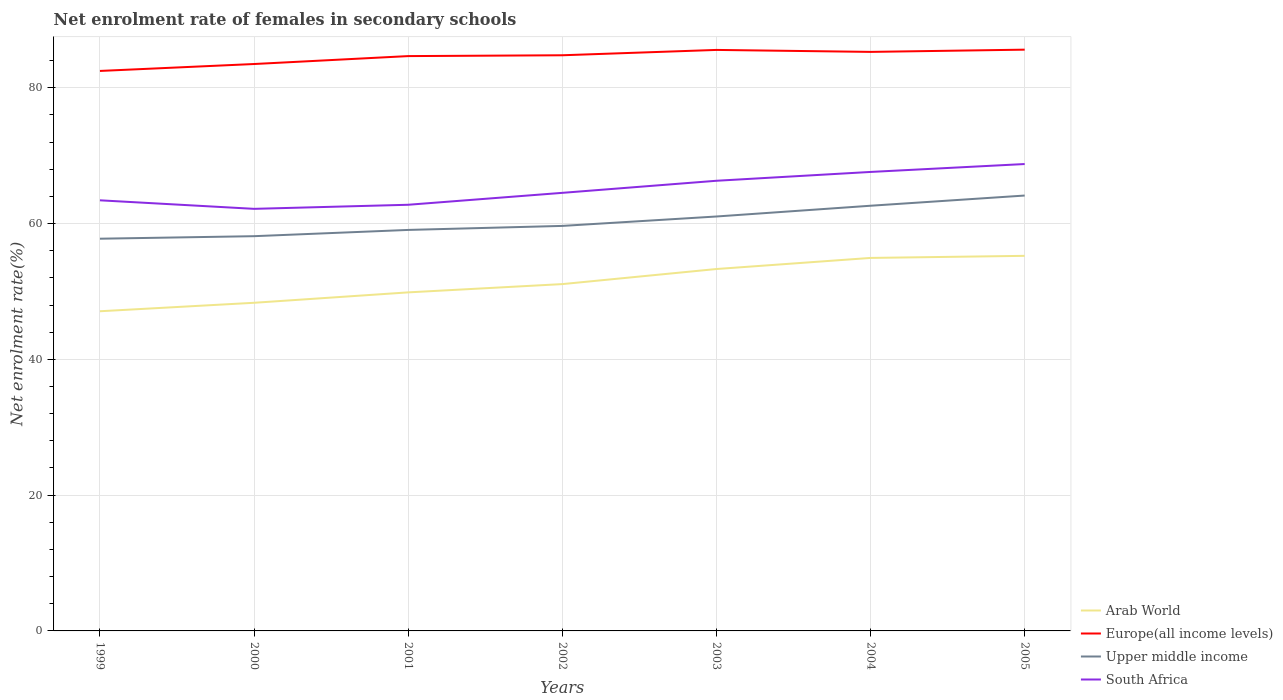How many different coloured lines are there?
Provide a short and direct response. 4. Is the number of lines equal to the number of legend labels?
Offer a very short reply. Yes. Across all years, what is the maximum net enrolment rate of females in secondary schools in Arab World?
Give a very brief answer. 47.08. In which year was the net enrolment rate of females in secondary schools in Upper middle income maximum?
Provide a short and direct response. 1999. What is the total net enrolment rate of females in secondary schools in South Africa in the graph?
Offer a very short reply. -1.78. What is the difference between the highest and the second highest net enrolment rate of females in secondary schools in Upper middle income?
Provide a succinct answer. 6.36. What is the difference between the highest and the lowest net enrolment rate of females in secondary schools in South Africa?
Your answer should be compact. 3. How many lines are there?
Give a very brief answer. 4. What is the difference between two consecutive major ticks on the Y-axis?
Provide a short and direct response. 20. How many legend labels are there?
Give a very brief answer. 4. How are the legend labels stacked?
Make the answer very short. Vertical. What is the title of the graph?
Offer a very short reply. Net enrolment rate of females in secondary schools. What is the label or title of the Y-axis?
Keep it short and to the point. Net enrolment rate(%). What is the Net enrolment rate(%) in Arab World in 1999?
Make the answer very short. 47.08. What is the Net enrolment rate(%) in Europe(all income levels) in 1999?
Your response must be concise. 82.48. What is the Net enrolment rate(%) in Upper middle income in 1999?
Your answer should be very brief. 57.77. What is the Net enrolment rate(%) in South Africa in 1999?
Your response must be concise. 63.43. What is the Net enrolment rate(%) in Arab World in 2000?
Provide a short and direct response. 48.33. What is the Net enrolment rate(%) of Europe(all income levels) in 2000?
Offer a terse response. 83.5. What is the Net enrolment rate(%) in Upper middle income in 2000?
Keep it short and to the point. 58.14. What is the Net enrolment rate(%) of South Africa in 2000?
Your response must be concise. 62.17. What is the Net enrolment rate(%) of Arab World in 2001?
Your response must be concise. 49.86. What is the Net enrolment rate(%) of Europe(all income levels) in 2001?
Your answer should be very brief. 84.67. What is the Net enrolment rate(%) of Upper middle income in 2001?
Provide a succinct answer. 59.06. What is the Net enrolment rate(%) in South Africa in 2001?
Provide a succinct answer. 62.77. What is the Net enrolment rate(%) in Arab World in 2002?
Offer a terse response. 51.08. What is the Net enrolment rate(%) of Europe(all income levels) in 2002?
Offer a very short reply. 84.79. What is the Net enrolment rate(%) in Upper middle income in 2002?
Provide a succinct answer. 59.65. What is the Net enrolment rate(%) of South Africa in 2002?
Your answer should be very brief. 64.52. What is the Net enrolment rate(%) of Arab World in 2003?
Ensure brevity in your answer.  53.31. What is the Net enrolment rate(%) in Europe(all income levels) in 2003?
Your answer should be compact. 85.58. What is the Net enrolment rate(%) of Upper middle income in 2003?
Provide a succinct answer. 61.04. What is the Net enrolment rate(%) of South Africa in 2003?
Give a very brief answer. 66.3. What is the Net enrolment rate(%) in Arab World in 2004?
Make the answer very short. 54.94. What is the Net enrolment rate(%) in Europe(all income levels) in 2004?
Offer a terse response. 85.29. What is the Net enrolment rate(%) of Upper middle income in 2004?
Offer a very short reply. 62.63. What is the Net enrolment rate(%) in South Africa in 2004?
Give a very brief answer. 67.6. What is the Net enrolment rate(%) in Arab World in 2005?
Your answer should be very brief. 55.25. What is the Net enrolment rate(%) of Europe(all income levels) in 2005?
Offer a very short reply. 85.62. What is the Net enrolment rate(%) of Upper middle income in 2005?
Make the answer very short. 64.13. What is the Net enrolment rate(%) in South Africa in 2005?
Your answer should be very brief. 68.77. Across all years, what is the maximum Net enrolment rate(%) of Arab World?
Offer a very short reply. 55.25. Across all years, what is the maximum Net enrolment rate(%) in Europe(all income levels)?
Provide a succinct answer. 85.62. Across all years, what is the maximum Net enrolment rate(%) in Upper middle income?
Your response must be concise. 64.13. Across all years, what is the maximum Net enrolment rate(%) in South Africa?
Ensure brevity in your answer.  68.77. Across all years, what is the minimum Net enrolment rate(%) of Arab World?
Provide a succinct answer. 47.08. Across all years, what is the minimum Net enrolment rate(%) in Europe(all income levels)?
Offer a terse response. 82.48. Across all years, what is the minimum Net enrolment rate(%) of Upper middle income?
Make the answer very short. 57.77. Across all years, what is the minimum Net enrolment rate(%) of South Africa?
Offer a terse response. 62.17. What is the total Net enrolment rate(%) of Arab World in the graph?
Provide a short and direct response. 359.86. What is the total Net enrolment rate(%) in Europe(all income levels) in the graph?
Offer a terse response. 591.91. What is the total Net enrolment rate(%) of Upper middle income in the graph?
Offer a terse response. 422.43. What is the total Net enrolment rate(%) in South Africa in the graph?
Give a very brief answer. 455.56. What is the difference between the Net enrolment rate(%) in Arab World in 1999 and that in 2000?
Ensure brevity in your answer.  -1.25. What is the difference between the Net enrolment rate(%) in Europe(all income levels) in 1999 and that in 2000?
Your answer should be compact. -1.02. What is the difference between the Net enrolment rate(%) in Upper middle income in 1999 and that in 2000?
Offer a very short reply. -0.37. What is the difference between the Net enrolment rate(%) in South Africa in 1999 and that in 2000?
Provide a short and direct response. 1.26. What is the difference between the Net enrolment rate(%) in Arab World in 1999 and that in 2001?
Offer a terse response. -2.78. What is the difference between the Net enrolment rate(%) of Europe(all income levels) in 1999 and that in 2001?
Provide a succinct answer. -2.19. What is the difference between the Net enrolment rate(%) of Upper middle income in 1999 and that in 2001?
Ensure brevity in your answer.  -1.29. What is the difference between the Net enrolment rate(%) in South Africa in 1999 and that in 2001?
Offer a very short reply. 0.66. What is the difference between the Net enrolment rate(%) of Arab World in 1999 and that in 2002?
Make the answer very short. -4. What is the difference between the Net enrolment rate(%) of Europe(all income levels) in 1999 and that in 2002?
Give a very brief answer. -2.31. What is the difference between the Net enrolment rate(%) in Upper middle income in 1999 and that in 2002?
Your answer should be very brief. -1.88. What is the difference between the Net enrolment rate(%) in South Africa in 1999 and that in 2002?
Offer a very short reply. -1.1. What is the difference between the Net enrolment rate(%) in Arab World in 1999 and that in 2003?
Provide a short and direct response. -6.22. What is the difference between the Net enrolment rate(%) in Europe(all income levels) in 1999 and that in 2003?
Offer a very short reply. -3.09. What is the difference between the Net enrolment rate(%) in Upper middle income in 1999 and that in 2003?
Your response must be concise. -3.27. What is the difference between the Net enrolment rate(%) in South Africa in 1999 and that in 2003?
Your answer should be compact. -2.88. What is the difference between the Net enrolment rate(%) of Arab World in 1999 and that in 2004?
Your answer should be compact. -7.86. What is the difference between the Net enrolment rate(%) of Europe(all income levels) in 1999 and that in 2004?
Provide a short and direct response. -2.8. What is the difference between the Net enrolment rate(%) in Upper middle income in 1999 and that in 2004?
Keep it short and to the point. -4.86. What is the difference between the Net enrolment rate(%) of South Africa in 1999 and that in 2004?
Your answer should be compact. -4.18. What is the difference between the Net enrolment rate(%) in Arab World in 1999 and that in 2005?
Your response must be concise. -8.16. What is the difference between the Net enrolment rate(%) of Europe(all income levels) in 1999 and that in 2005?
Give a very brief answer. -3.13. What is the difference between the Net enrolment rate(%) in Upper middle income in 1999 and that in 2005?
Keep it short and to the point. -6.36. What is the difference between the Net enrolment rate(%) of South Africa in 1999 and that in 2005?
Make the answer very short. -5.34. What is the difference between the Net enrolment rate(%) in Arab World in 2000 and that in 2001?
Make the answer very short. -1.53. What is the difference between the Net enrolment rate(%) in Europe(all income levels) in 2000 and that in 2001?
Keep it short and to the point. -1.17. What is the difference between the Net enrolment rate(%) of Upper middle income in 2000 and that in 2001?
Keep it short and to the point. -0.92. What is the difference between the Net enrolment rate(%) in South Africa in 2000 and that in 2001?
Your answer should be very brief. -0.6. What is the difference between the Net enrolment rate(%) in Arab World in 2000 and that in 2002?
Provide a short and direct response. -2.75. What is the difference between the Net enrolment rate(%) of Europe(all income levels) in 2000 and that in 2002?
Provide a short and direct response. -1.29. What is the difference between the Net enrolment rate(%) in Upper middle income in 2000 and that in 2002?
Your response must be concise. -1.51. What is the difference between the Net enrolment rate(%) in South Africa in 2000 and that in 2002?
Offer a terse response. -2.36. What is the difference between the Net enrolment rate(%) in Arab World in 2000 and that in 2003?
Provide a short and direct response. -4.97. What is the difference between the Net enrolment rate(%) in Europe(all income levels) in 2000 and that in 2003?
Your answer should be compact. -2.08. What is the difference between the Net enrolment rate(%) of Upper middle income in 2000 and that in 2003?
Make the answer very short. -2.9. What is the difference between the Net enrolment rate(%) in South Africa in 2000 and that in 2003?
Make the answer very short. -4.14. What is the difference between the Net enrolment rate(%) in Arab World in 2000 and that in 2004?
Keep it short and to the point. -6.61. What is the difference between the Net enrolment rate(%) in Europe(all income levels) in 2000 and that in 2004?
Provide a succinct answer. -1.79. What is the difference between the Net enrolment rate(%) of Upper middle income in 2000 and that in 2004?
Offer a terse response. -4.48. What is the difference between the Net enrolment rate(%) of South Africa in 2000 and that in 2004?
Make the answer very short. -5.44. What is the difference between the Net enrolment rate(%) in Arab World in 2000 and that in 2005?
Your answer should be compact. -6.91. What is the difference between the Net enrolment rate(%) in Europe(all income levels) in 2000 and that in 2005?
Ensure brevity in your answer.  -2.12. What is the difference between the Net enrolment rate(%) of Upper middle income in 2000 and that in 2005?
Your answer should be compact. -5.99. What is the difference between the Net enrolment rate(%) of South Africa in 2000 and that in 2005?
Your response must be concise. -6.6. What is the difference between the Net enrolment rate(%) of Arab World in 2001 and that in 2002?
Keep it short and to the point. -1.22. What is the difference between the Net enrolment rate(%) of Europe(all income levels) in 2001 and that in 2002?
Your response must be concise. -0.12. What is the difference between the Net enrolment rate(%) in Upper middle income in 2001 and that in 2002?
Provide a succinct answer. -0.59. What is the difference between the Net enrolment rate(%) of South Africa in 2001 and that in 2002?
Make the answer very short. -1.76. What is the difference between the Net enrolment rate(%) in Arab World in 2001 and that in 2003?
Your answer should be very brief. -3.44. What is the difference between the Net enrolment rate(%) in Europe(all income levels) in 2001 and that in 2003?
Ensure brevity in your answer.  -0.91. What is the difference between the Net enrolment rate(%) of Upper middle income in 2001 and that in 2003?
Provide a short and direct response. -1.98. What is the difference between the Net enrolment rate(%) of South Africa in 2001 and that in 2003?
Keep it short and to the point. -3.54. What is the difference between the Net enrolment rate(%) of Arab World in 2001 and that in 2004?
Your response must be concise. -5.08. What is the difference between the Net enrolment rate(%) of Europe(all income levels) in 2001 and that in 2004?
Keep it short and to the point. -0.62. What is the difference between the Net enrolment rate(%) in Upper middle income in 2001 and that in 2004?
Make the answer very short. -3.56. What is the difference between the Net enrolment rate(%) in South Africa in 2001 and that in 2004?
Offer a very short reply. -4.84. What is the difference between the Net enrolment rate(%) in Arab World in 2001 and that in 2005?
Provide a short and direct response. -5.38. What is the difference between the Net enrolment rate(%) in Europe(all income levels) in 2001 and that in 2005?
Make the answer very short. -0.95. What is the difference between the Net enrolment rate(%) of Upper middle income in 2001 and that in 2005?
Your answer should be compact. -5.07. What is the difference between the Net enrolment rate(%) of South Africa in 2001 and that in 2005?
Provide a short and direct response. -6. What is the difference between the Net enrolment rate(%) of Arab World in 2002 and that in 2003?
Ensure brevity in your answer.  -2.22. What is the difference between the Net enrolment rate(%) of Europe(all income levels) in 2002 and that in 2003?
Keep it short and to the point. -0.79. What is the difference between the Net enrolment rate(%) of Upper middle income in 2002 and that in 2003?
Make the answer very short. -1.39. What is the difference between the Net enrolment rate(%) in South Africa in 2002 and that in 2003?
Make the answer very short. -1.78. What is the difference between the Net enrolment rate(%) in Arab World in 2002 and that in 2004?
Ensure brevity in your answer.  -3.86. What is the difference between the Net enrolment rate(%) of Europe(all income levels) in 2002 and that in 2004?
Provide a succinct answer. -0.5. What is the difference between the Net enrolment rate(%) of Upper middle income in 2002 and that in 2004?
Your answer should be very brief. -2.97. What is the difference between the Net enrolment rate(%) in South Africa in 2002 and that in 2004?
Your response must be concise. -3.08. What is the difference between the Net enrolment rate(%) of Arab World in 2002 and that in 2005?
Ensure brevity in your answer.  -4.16. What is the difference between the Net enrolment rate(%) in Europe(all income levels) in 2002 and that in 2005?
Give a very brief answer. -0.83. What is the difference between the Net enrolment rate(%) of Upper middle income in 2002 and that in 2005?
Provide a succinct answer. -4.47. What is the difference between the Net enrolment rate(%) of South Africa in 2002 and that in 2005?
Offer a terse response. -4.24. What is the difference between the Net enrolment rate(%) in Arab World in 2003 and that in 2004?
Provide a short and direct response. -1.63. What is the difference between the Net enrolment rate(%) of Europe(all income levels) in 2003 and that in 2004?
Keep it short and to the point. 0.29. What is the difference between the Net enrolment rate(%) of Upper middle income in 2003 and that in 2004?
Keep it short and to the point. -1.58. What is the difference between the Net enrolment rate(%) in South Africa in 2003 and that in 2004?
Make the answer very short. -1.3. What is the difference between the Net enrolment rate(%) of Arab World in 2003 and that in 2005?
Provide a short and direct response. -1.94. What is the difference between the Net enrolment rate(%) in Europe(all income levels) in 2003 and that in 2005?
Provide a short and direct response. -0.04. What is the difference between the Net enrolment rate(%) in Upper middle income in 2003 and that in 2005?
Offer a terse response. -3.09. What is the difference between the Net enrolment rate(%) of South Africa in 2003 and that in 2005?
Your answer should be very brief. -2.46. What is the difference between the Net enrolment rate(%) of Arab World in 2004 and that in 2005?
Make the answer very short. -0.31. What is the difference between the Net enrolment rate(%) of Europe(all income levels) in 2004 and that in 2005?
Your answer should be very brief. -0.33. What is the difference between the Net enrolment rate(%) of Upper middle income in 2004 and that in 2005?
Keep it short and to the point. -1.5. What is the difference between the Net enrolment rate(%) of South Africa in 2004 and that in 2005?
Your answer should be compact. -1.16. What is the difference between the Net enrolment rate(%) in Arab World in 1999 and the Net enrolment rate(%) in Europe(all income levels) in 2000?
Provide a succinct answer. -36.42. What is the difference between the Net enrolment rate(%) in Arab World in 1999 and the Net enrolment rate(%) in Upper middle income in 2000?
Make the answer very short. -11.06. What is the difference between the Net enrolment rate(%) of Arab World in 1999 and the Net enrolment rate(%) of South Africa in 2000?
Offer a terse response. -15.09. What is the difference between the Net enrolment rate(%) in Europe(all income levels) in 1999 and the Net enrolment rate(%) in Upper middle income in 2000?
Offer a very short reply. 24.34. What is the difference between the Net enrolment rate(%) in Europe(all income levels) in 1999 and the Net enrolment rate(%) in South Africa in 2000?
Provide a short and direct response. 20.31. What is the difference between the Net enrolment rate(%) of Upper middle income in 1999 and the Net enrolment rate(%) of South Africa in 2000?
Offer a very short reply. -4.4. What is the difference between the Net enrolment rate(%) in Arab World in 1999 and the Net enrolment rate(%) in Europe(all income levels) in 2001?
Ensure brevity in your answer.  -37.58. What is the difference between the Net enrolment rate(%) in Arab World in 1999 and the Net enrolment rate(%) in Upper middle income in 2001?
Your answer should be very brief. -11.98. What is the difference between the Net enrolment rate(%) in Arab World in 1999 and the Net enrolment rate(%) in South Africa in 2001?
Your answer should be very brief. -15.68. What is the difference between the Net enrolment rate(%) in Europe(all income levels) in 1999 and the Net enrolment rate(%) in Upper middle income in 2001?
Keep it short and to the point. 23.42. What is the difference between the Net enrolment rate(%) of Europe(all income levels) in 1999 and the Net enrolment rate(%) of South Africa in 2001?
Your answer should be compact. 19.71. What is the difference between the Net enrolment rate(%) of Upper middle income in 1999 and the Net enrolment rate(%) of South Africa in 2001?
Your answer should be very brief. -5. What is the difference between the Net enrolment rate(%) in Arab World in 1999 and the Net enrolment rate(%) in Europe(all income levels) in 2002?
Provide a short and direct response. -37.71. What is the difference between the Net enrolment rate(%) in Arab World in 1999 and the Net enrolment rate(%) in Upper middle income in 2002?
Provide a short and direct response. -12.57. What is the difference between the Net enrolment rate(%) in Arab World in 1999 and the Net enrolment rate(%) in South Africa in 2002?
Your answer should be compact. -17.44. What is the difference between the Net enrolment rate(%) in Europe(all income levels) in 1999 and the Net enrolment rate(%) in Upper middle income in 2002?
Give a very brief answer. 22.83. What is the difference between the Net enrolment rate(%) of Europe(all income levels) in 1999 and the Net enrolment rate(%) of South Africa in 2002?
Offer a terse response. 17.96. What is the difference between the Net enrolment rate(%) in Upper middle income in 1999 and the Net enrolment rate(%) in South Africa in 2002?
Your answer should be very brief. -6.75. What is the difference between the Net enrolment rate(%) in Arab World in 1999 and the Net enrolment rate(%) in Europe(all income levels) in 2003?
Ensure brevity in your answer.  -38.49. What is the difference between the Net enrolment rate(%) in Arab World in 1999 and the Net enrolment rate(%) in Upper middle income in 2003?
Give a very brief answer. -13.96. What is the difference between the Net enrolment rate(%) in Arab World in 1999 and the Net enrolment rate(%) in South Africa in 2003?
Keep it short and to the point. -19.22. What is the difference between the Net enrolment rate(%) in Europe(all income levels) in 1999 and the Net enrolment rate(%) in Upper middle income in 2003?
Offer a terse response. 21.44. What is the difference between the Net enrolment rate(%) in Europe(all income levels) in 1999 and the Net enrolment rate(%) in South Africa in 2003?
Offer a very short reply. 16.18. What is the difference between the Net enrolment rate(%) in Upper middle income in 1999 and the Net enrolment rate(%) in South Africa in 2003?
Keep it short and to the point. -8.53. What is the difference between the Net enrolment rate(%) in Arab World in 1999 and the Net enrolment rate(%) in Europe(all income levels) in 2004?
Offer a very short reply. -38.2. What is the difference between the Net enrolment rate(%) of Arab World in 1999 and the Net enrolment rate(%) of Upper middle income in 2004?
Offer a terse response. -15.54. What is the difference between the Net enrolment rate(%) of Arab World in 1999 and the Net enrolment rate(%) of South Africa in 2004?
Keep it short and to the point. -20.52. What is the difference between the Net enrolment rate(%) in Europe(all income levels) in 1999 and the Net enrolment rate(%) in Upper middle income in 2004?
Offer a terse response. 19.85. What is the difference between the Net enrolment rate(%) of Europe(all income levels) in 1999 and the Net enrolment rate(%) of South Africa in 2004?
Your response must be concise. 14.88. What is the difference between the Net enrolment rate(%) in Upper middle income in 1999 and the Net enrolment rate(%) in South Africa in 2004?
Provide a short and direct response. -9.83. What is the difference between the Net enrolment rate(%) in Arab World in 1999 and the Net enrolment rate(%) in Europe(all income levels) in 2005?
Your response must be concise. -38.53. What is the difference between the Net enrolment rate(%) in Arab World in 1999 and the Net enrolment rate(%) in Upper middle income in 2005?
Give a very brief answer. -17.04. What is the difference between the Net enrolment rate(%) in Arab World in 1999 and the Net enrolment rate(%) in South Africa in 2005?
Your response must be concise. -21.68. What is the difference between the Net enrolment rate(%) in Europe(all income levels) in 1999 and the Net enrolment rate(%) in Upper middle income in 2005?
Your answer should be very brief. 18.35. What is the difference between the Net enrolment rate(%) of Europe(all income levels) in 1999 and the Net enrolment rate(%) of South Africa in 2005?
Your answer should be very brief. 13.71. What is the difference between the Net enrolment rate(%) in Upper middle income in 1999 and the Net enrolment rate(%) in South Africa in 2005?
Give a very brief answer. -11. What is the difference between the Net enrolment rate(%) of Arab World in 2000 and the Net enrolment rate(%) of Europe(all income levels) in 2001?
Provide a short and direct response. -36.34. What is the difference between the Net enrolment rate(%) of Arab World in 2000 and the Net enrolment rate(%) of Upper middle income in 2001?
Offer a terse response. -10.73. What is the difference between the Net enrolment rate(%) of Arab World in 2000 and the Net enrolment rate(%) of South Africa in 2001?
Offer a terse response. -14.44. What is the difference between the Net enrolment rate(%) in Europe(all income levels) in 2000 and the Net enrolment rate(%) in Upper middle income in 2001?
Ensure brevity in your answer.  24.44. What is the difference between the Net enrolment rate(%) of Europe(all income levels) in 2000 and the Net enrolment rate(%) of South Africa in 2001?
Give a very brief answer. 20.73. What is the difference between the Net enrolment rate(%) of Upper middle income in 2000 and the Net enrolment rate(%) of South Africa in 2001?
Offer a terse response. -4.63. What is the difference between the Net enrolment rate(%) in Arab World in 2000 and the Net enrolment rate(%) in Europe(all income levels) in 2002?
Offer a very short reply. -36.46. What is the difference between the Net enrolment rate(%) in Arab World in 2000 and the Net enrolment rate(%) in Upper middle income in 2002?
Your answer should be compact. -11.32. What is the difference between the Net enrolment rate(%) of Arab World in 2000 and the Net enrolment rate(%) of South Africa in 2002?
Give a very brief answer. -16.19. What is the difference between the Net enrolment rate(%) of Europe(all income levels) in 2000 and the Net enrolment rate(%) of Upper middle income in 2002?
Provide a short and direct response. 23.84. What is the difference between the Net enrolment rate(%) of Europe(all income levels) in 2000 and the Net enrolment rate(%) of South Africa in 2002?
Make the answer very short. 18.97. What is the difference between the Net enrolment rate(%) in Upper middle income in 2000 and the Net enrolment rate(%) in South Africa in 2002?
Ensure brevity in your answer.  -6.38. What is the difference between the Net enrolment rate(%) in Arab World in 2000 and the Net enrolment rate(%) in Europe(all income levels) in 2003?
Ensure brevity in your answer.  -37.24. What is the difference between the Net enrolment rate(%) of Arab World in 2000 and the Net enrolment rate(%) of Upper middle income in 2003?
Make the answer very short. -12.71. What is the difference between the Net enrolment rate(%) in Arab World in 2000 and the Net enrolment rate(%) in South Africa in 2003?
Your response must be concise. -17.97. What is the difference between the Net enrolment rate(%) of Europe(all income levels) in 2000 and the Net enrolment rate(%) of Upper middle income in 2003?
Your response must be concise. 22.46. What is the difference between the Net enrolment rate(%) of Europe(all income levels) in 2000 and the Net enrolment rate(%) of South Africa in 2003?
Keep it short and to the point. 17.19. What is the difference between the Net enrolment rate(%) of Upper middle income in 2000 and the Net enrolment rate(%) of South Africa in 2003?
Provide a succinct answer. -8.16. What is the difference between the Net enrolment rate(%) in Arab World in 2000 and the Net enrolment rate(%) in Europe(all income levels) in 2004?
Your answer should be very brief. -36.95. What is the difference between the Net enrolment rate(%) of Arab World in 2000 and the Net enrolment rate(%) of Upper middle income in 2004?
Give a very brief answer. -14.29. What is the difference between the Net enrolment rate(%) of Arab World in 2000 and the Net enrolment rate(%) of South Africa in 2004?
Provide a succinct answer. -19.27. What is the difference between the Net enrolment rate(%) in Europe(all income levels) in 2000 and the Net enrolment rate(%) in Upper middle income in 2004?
Your answer should be compact. 20.87. What is the difference between the Net enrolment rate(%) in Europe(all income levels) in 2000 and the Net enrolment rate(%) in South Africa in 2004?
Provide a succinct answer. 15.9. What is the difference between the Net enrolment rate(%) of Upper middle income in 2000 and the Net enrolment rate(%) of South Africa in 2004?
Make the answer very short. -9.46. What is the difference between the Net enrolment rate(%) of Arab World in 2000 and the Net enrolment rate(%) of Europe(all income levels) in 2005?
Give a very brief answer. -37.28. What is the difference between the Net enrolment rate(%) in Arab World in 2000 and the Net enrolment rate(%) in Upper middle income in 2005?
Your answer should be very brief. -15.8. What is the difference between the Net enrolment rate(%) of Arab World in 2000 and the Net enrolment rate(%) of South Africa in 2005?
Provide a succinct answer. -20.44. What is the difference between the Net enrolment rate(%) in Europe(all income levels) in 2000 and the Net enrolment rate(%) in Upper middle income in 2005?
Provide a succinct answer. 19.37. What is the difference between the Net enrolment rate(%) in Europe(all income levels) in 2000 and the Net enrolment rate(%) in South Africa in 2005?
Your answer should be very brief. 14.73. What is the difference between the Net enrolment rate(%) of Upper middle income in 2000 and the Net enrolment rate(%) of South Africa in 2005?
Your answer should be very brief. -10.63. What is the difference between the Net enrolment rate(%) in Arab World in 2001 and the Net enrolment rate(%) in Europe(all income levels) in 2002?
Offer a very short reply. -34.92. What is the difference between the Net enrolment rate(%) of Arab World in 2001 and the Net enrolment rate(%) of Upper middle income in 2002?
Offer a very short reply. -9.79. What is the difference between the Net enrolment rate(%) in Arab World in 2001 and the Net enrolment rate(%) in South Africa in 2002?
Ensure brevity in your answer.  -14.66. What is the difference between the Net enrolment rate(%) in Europe(all income levels) in 2001 and the Net enrolment rate(%) in Upper middle income in 2002?
Ensure brevity in your answer.  25.01. What is the difference between the Net enrolment rate(%) in Europe(all income levels) in 2001 and the Net enrolment rate(%) in South Africa in 2002?
Offer a very short reply. 20.14. What is the difference between the Net enrolment rate(%) of Upper middle income in 2001 and the Net enrolment rate(%) of South Africa in 2002?
Ensure brevity in your answer.  -5.46. What is the difference between the Net enrolment rate(%) of Arab World in 2001 and the Net enrolment rate(%) of Europe(all income levels) in 2003?
Provide a succinct answer. -35.71. What is the difference between the Net enrolment rate(%) in Arab World in 2001 and the Net enrolment rate(%) in Upper middle income in 2003?
Keep it short and to the point. -11.18. What is the difference between the Net enrolment rate(%) of Arab World in 2001 and the Net enrolment rate(%) of South Africa in 2003?
Make the answer very short. -16.44. What is the difference between the Net enrolment rate(%) of Europe(all income levels) in 2001 and the Net enrolment rate(%) of Upper middle income in 2003?
Give a very brief answer. 23.63. What is the difference between the Net enrolment rate(%) of Europe(all income levels) in 2001 and the Net enrolment rate(%) of South Africa in 2003?
Provide a succinct answer. 18.36. What is the difference between the Net enrolment rate(%) of Upper middle income in 2001 and the Net enrolment rate(%) of South Africa in 2003?
Keep it short and to the point. -7.24. What is the difference between the Net enrolment rate(%) of Arab World in 2001 and the Net enrolment rate(%) of Europe(all income levels) in 2004?
Offer a very short reply. -35.42. What is the difference between the Net enrolment rate(%) in Arab World in 2001 and the Net enrolment rate(%) in Upper middle income in 2004?
Your answer should be compact. -12.76. What is the difference between the Net enrolment rate(%) in Arab World in 2001 and the Net enrolment rate(%) in South Africa in 2004?
Offer a terse response. -17.74. What is the difference between the Net enrolment rate(%) of Europe(all income levels) in 2001 and the Net enrolment rate(%) of Upper middle income in 2004?
Ensure brevity in your answer.  22.04. What is the difference between the Net enrolment rate(%) in Europe(all income levels) in 2001 and the Net enrolment rate(%) in South Africa in 2004?
Make the answer very short. 17.06. What is the difference between the Net enrolment rate(%) of Upper middle income in 2001 and the Net enrolment rate(%) of South Africa in 2004?
Ensure brevity in your answer.  -8.54. What is the difference between the Net enrolment rate(%) of Arab World in 2001 and the Net enrolment rate(%) of Europe(all income levels) in 2005?
Your answer should be compact. -35.75. What is the difference between the Net enrolment rate(%) of Arab World in 2001 and the Net enrolment rate(%) of Upper middle income in 2005?
Provide a succinct answer. -14.26. What is the difference between the Net enrolment rate(%) in Arab World in 2001 and the Net enrolment rate(%) in South Africa in 2005?
Ensure brevity in your answer.  -18.9. What is the difference between the Net enrolment rate(%) in Europe(all income levels) in 2001 and the Net enrolment rate(%) in Upper middle income in 2005?
Keep it short and to the point. 20.54. What is the difference between the Net enrolment rate(%) of Europe(all income levels) in 2001 and the Net enrolment rate(%) of South Africa in 2005?
Give a very brief answer. 15.9. What is the difference between the Net enrolment rate(%) of Upper middle income in 2001 and the Net enrolment rate(%) of South Africa in 2005?
Make the answer very short. -9.71. What is the difference between the Net enrolment rate(%) of Arab World in 2002 and the Net enrolment rate(%) of Europe(all income levels) in 2003?
Offer a terse response. -34.49. What is the difference between the Net enrolment rate(%) of Arab World in 2002 and the Net enrolment rate(%) of Upper middle income in 2003?
Make the answer very short. -9.96. What is the difference between the Net enrolment rate(%) of Arab World in 2002 and the Net enrolment rate(%) of South Africa in 2003?
Keep it short and to the point. -15.22. What is the difference between the Net enrolment rate(%) of Europe(all income levels) in 2002 and the Net enrolment rate(%) of Upper middle income in 2003?
Keep it short and to the point. 23.75. What is the difference between the Net enrolment rate(%) of Europe(all income levels) in 2002 and the Net enrolment rate(%) of South Africa in 2003?
Keep it short and to the point. 18.48. What is the difference between the Net enrolment rate(%) in Upper middle income in 2002 and the Net enrolment rate(%) in South Africa in 2003?
Give a very brief answer. -6.65. What is the difference between the Net enrolment rate(%) in Arab World in 2002 and the Net enrolment rate(%) in Europe(all income levels) in 2004?
Provide a short and direct response. -34.2. What is the difference between the Net enrolment rate(%) in Arab World in 2002 and the Net enrolment rate(%) in Upper middle income in 2004?
Provide a short and direct response. -11.54. What is the difference between the Net enrolment rate(%) in Arab World in 2002 and the Net enrolment rate(%) in South Africa in 2004?
Give a very brief answer. -16.52. What is the difference between the Net enrolment rate(%) in Europe(all income levels) in 2002 and the Net enrolment rate(%) in Upper middle income in 2004?
Give a very brief answer. 22.16. What is the difference between the Net enrolment rate(%) of Europe(all income levels) in 2002 and the Net enrolment rate(%) of South Africa in 2004?
Give a very brief answer. 17.18. What is the difference between the Net enrolment rate(%) of Upper middle income in 2002 and the Net enrolment rate(%) of South Africa in 2004?
Keep it short and to the point. -7.95. What is the difference between the Net enrolment rate(%) of Arab World in 2002 and the Net enrolment rate(%) of Europe(all income levels) in 2005?
Provide a short and direct response. -34.53. What is the difference between the Net enrolment rate(%) of Arab World in 2002 and the Net enrolment rate(%) of Upper middle income in 2005?
Offer a terse response. -13.04. What is the difference between the Net enrolment rate(%) in Arab World in 2002 and the Net enrolment rate(%) in South Africa in 2005?
Offer a terse response. -17.68. What is the difference between the Net enrolment rate(%) of Europe(all income levels) in 2002 and the Net enrolment rate(%) of Upper middle income in 2005?
Give a very brief answer. 20.66. What is the difference between the Net enrolment rate(%) of Europe(all income levels) in 2002 and the Net enrolment rate(%) of South Africa in 2005?
Make the answer very short. 16.02. What is the difference between the Net enrolment rate(%) in Upper middle income in 2002 and the Net enrolment rate(%) in South Africa in 2005?
Ensure brevity in your answer.  -9.11. What is the difference between the Net enrolment rate(%) in Arab World in 2003 and the Net enrolment rate(%) in Europe(all income levels) in 2004?
Make the answer very short. -31.98. What is the difference between the Net enrolment rate(%) of Arab World in 2003 and the Net enrolment rate(%) of Upper middle income in 2004?
Make the answer very short. -9.32. What is the difference between the Net enrolment rate(%) of Arab World in 2003 and the Net enrolment rate(%) of South Africa in 2004?
Your answer should be compact. -14.3. What is the difference between the Net enrolment rate(%) of Europe(all income levels) in 2003 and the Net enrolment rate(%) of Upper middle income in 2004?
Your answer should be compact. 22.95. What is the difference between the Net enrolment rate(%) of Europe(all income levels) in 2003 and the Net enrolment rate(%) of South Africa in 2004?
Ensure brevity in your answer.  17.97. What is the difference between the Net enrolment rate(%) in Upper middle income in 2003 and the Net enrolment rate(%) in South Africa in 2004?
Provide a succinct answer. -6.56. What is the difference between the Net enrolment rate(%) in Arab World in 2003 and the Net enrolment rate(%) in Europe(all income levels) in 2005?
Offer a terse response. -32.31. What is the difference between the Net enrolment rate(%) of Arab World in 2003 and the Net enrolment rate(%) of Upper middle income in 2005?
Make the answer very short. -10.82. What is the difference between the Net enrolment rate(%) in Arab World in 2003 and the Net enrolment rate(%) in South Africa in 2005?
Provide a succinct answer. -15.46. What is the difference between the Net enrolment rate(%) in Europe(all income levels) in 2003 and the Net enrolment rate(%) in Upper middle income in 2005?
Make the answer very short. 21.45. What is the difference between the Net enrolment rate(%) of Europe(all income levels) in 2003 and the Net enrolment rate(%) of South Africa in 2005?
Ensure brevity in your answer.  16.81. What is the difference between the Net enrolment rate(%) of Upper middle income in 2003 and the Net enrolment rate(%) of South Africa in 2005?
Your response must be concise. -7.73. What is the difference between the Net enrolment rate(%) of Arab World in 2004 and the Net enrolment rate(%) of Europe(all income levels) in 2005?
Offer a terse response. -30.68. What is the difference between the Net enrolment rate(%) in Arab World in 2004 and the Net enrolment rate(%) in Upper middle income in 2005?
Provide a short and direct response. -9.19. What is the difference between the Net enrolment rate(%) of Arab World in 2004 and the Net enrolment rate(%) of South Africa in 2005?
Offer a terse response. -13.83. What is the difference between the Net enrolment rate(%) in Europe(all income levels) in 2004 and the Net enrolment rate(%) in Upper middle income in 2005?
Your answer should be very brief. 21.16. What is the difference between the Net enrolment rate(%) of Europe(all income levels) in 2004 and the Net enrolment rate(%) of South Africa in 2005?
Your response must be concise. 16.52. What is the difference between the Net enrolment rate(%) of Upper middle income in 2004 and the Net enrolment rate(%) of South Africa in 2005?
Provide a short and direct response. -6.14. What is the average Net enrolment rate(%) in Arab World per year?
Offer a terse response. 51.41. What is the average Net enrolment rate(%) in Europe(all income levels) per year?
Ensure brevity in your answer.  84.56. What is the average Net enrolment rate(%) in Upper middle income per year?
Offer a very short reply. 60.35. What is the average Net enrolment rate(%) in South Africa per year?
Ensure brevity in your answer.  65.08. In the year 1999, what is the difference between the Net enrolment rate(%) of Arab World and Net enrolment rate(%) of Europe(all income levels)?
Ensure brevity in your answer.  -35.4. In the year 1999, what is the difference between the Net enrolment rate(%) of Arab World and Net enrolment rate(%) of Upper middle income?
Offer a very short reply. -10.69. In the year 1999, what is the difference between the Net enrolment rate(%) in Arab World and Net enrolment rate(%) in South Africa?
Offer a terse response. -16.34. In the year 1999, what is the difference between the Net enrolment rate(%) in Europe(all income levels) and Net enrolment rate(%) in Upper middle income?
Your answer should be very brief. 24.71. In the year 1999, what is the difference between the Net enrolment rate(%) of Europe(all income levels) and Net enrolment rate(%) of South Africa?
Make the answer very short. 19.06. In the year 1999, what is the difference between the Net enrolment rate(%) in Upper middle income and Net enrolment rate(%) in South Africa?
Your answer should be compact. -5.65. In the year 2000, what is the difference between the Net enrolment rate(%) of Arab World and Net enrolment rate(%) of Europe(all income levels)?
Your answer should be very brief. -35.17. In the year 2000, what is the difference between the Net enrolment rate(%) of Arab World and Net enrolment rate(%) of Upper middle income?
Your response must be concise. -9.81. In the year 2000, what is the difference between the Net enrolment rate(%) in Arab World and Net enrolment rate(%) in South Africa?
Give a very brief answer. -13.84. In the year 2000, what is the difference between the Net enrolment rate(%) of Europe(all income levels) and Net enrolment rate(%) of Upper middle income?
Keep it short and to the point. 25.36. In the year 2000, what is the difference between the Net enrolment rate(%) of Europe(all income levels) and Net enrolment rate(%) of South Africa?
Your response must be concise. 21.33. In the year 2000, what is the difference between the Net enrolment rate(%) in Upper middle income and Net enrolment rate(%) in South Africa?
Make the answer very short. -4.03. In the year 2001, what is the difference between the Net enrolment rate(%) in Arab World and Net enrolment rate(%) in Europe(all income levels)?
Give a very brief answer. -34.8. In the year 2001, what is the difference between the Net enrolment rate(%) of Arab World and Net enrolment rate(%) of Upper middle income?
Give a very brief answer. -9.2. In the year 2001, what is the difference between the Net enrolment rate(%) in Arab World and Net enrolment rate(%) in South Africa?
Provide a short and direct response. -12.9. In the year 2001, what is the difference between the Net enrolment rate(%) of Europe(all income levels) and Net enrolment rate(%) of Upper middle income?
Your answer should be compact. 25.6. In the year 2001, what is the difference between the Net enrolment rate(%) of Europe(all income levels) and Net enrolment rate(%) of South Africa?
Provide a succinct answer. 21.9. In the year 2001, what is the difference between the Net enrolment rate(%) of Upper middle income and Net enrolment rate(%) of South Africa?
Your answer should be very brief. -3.71. In the year 2002, what is the difference between the Net enrolment rate(%) of Arab World and Net enrolment rate(%) of Europe(all income levels)?
Your answer should be compact. -33.7. In the year 2002, what is the difference between the Net enrolment rate(%) in Arab World and Net enrolment rate(%) in Upper middle income?
Give a very brief answer. -8.57. In the year 2002, what is the difference between the Net enrolment rate(%) in Arab World and Net enrolment rate(%) in South Africa?
Provide a succinct answer. -13.44. In the year 2002, what is the difference between the Net enrolment rate(%) of Europe(all income levels) and Net enrolment rate(%) of Upper middle income?
Make the answer very short. 25.13. In the year 2002, what is the difference between the Net enrolment rate(%) in Europe(all income levels) and Net enrolment rate(%) in South Africa?
Your answer should be very brief. 20.26. In the year 2002, what is the difference between the Net enrolment rate(%) of Upper middle income and Net enrolment rate(%) of South Africa?
Give a very brief answer. -4.87. In the year 2003, what is the difference between the Net enrolment rate(%) of Arab World and Net enrolment rate(%) of Europe(all income levels)?
Provide a succinct answer. -32.27. In the year 2003, what is the difference between the Net enrolment rate(%) of Arab World and Net enrolment rate(%) of Upper middle income?
Your answer should be very brief. -7.74. In the year 2003, what is the difference between the Net enrolment rate(%) in Arab World and Net enrolment rate(%) in South Africa?
Make the answer very short. -13. In the year 2003, what is the difference between the Net enrolment rate(%) of Europe(all income levels) and Net enrolment rate(%) of Upper middle income?
Provide a short and direct response. 24.53. In the year 2003, what is the difference between the Net enrolment rate(%) in Europe(all income levels) and Net enrolment rate(%) in South Africa?
Make the answer very short. 19.27. In the year 2003, what is the difference between the Net enrolment rate(%) in Upper middle income and Net enrolment rate(%) in South Africa?
Provide a succinct answer. -5.26. In the year 2004, what is the difference between the Net enrolment rate(%) of Arab World and Net enrolment rate(%) of Europe(all income levels)?
Provide a short and direct response. -30.35. In the year 2004, what is the difference between the Net enrolment rate(%) in Arab World and Net enrolment rate(%) in Upper middle income?
Make the answer very short. -7.69. In the year 2004, what is the difference between the Net enrolment rate(%) of Arab World and Net enrolment rate(%) of South Africa?
Ensure brevity in your answer.  -12.66. In the year 2004, what is the difference between the Net enrolment rate(%) in Europe(all income levels) and Net enrolment rate(%) in Upper middle income?
Offer a terse response. 22.66. In the year 2004, what is the difference between the Net enrolment rate(%) in Europe(all income levels) and Net enrolment rate(%) in South Africa?
Make the answer very short. 17.68. In the year 2004, what is the difference between the Net enrolment rate(%) of Upper middle income and Net enrolment rate(%) of South Africa?
Provide a short and direct response. -4.98. In the year 2005, what is the difference between the Net enrolment rate(%) of Arab World and Net enrolment rate(%) of Europe(all income levels)?
Provide a short and direct response. -30.37. In the year 2005, what is the difference between the Net enrolment rate(%) in Arab World and Net enrolment rate(%) in Upper middle income?
Your response must be concise. -8.88. In the year 2005, what is the difference between the Net enrolment rate(%) of Arab World and Net enrolment rate(%) of South Africa?
Provide a succinct answer. -13.52. In the year 2005, what is the difference between the Net enrolment rate(%) of Europe(all income levels) and Net enrolment rate(%) of Upper middle income?
Offer a terse response. 21.49. In the year 2005, what is the difference between the Net enrolment rate(%) of Europe(all income levels) and Net enrolment rate(%) of South Africa?
Provide a short and direct response. 16.85. In the year 2005, what is the difference between the Net enrolment rate(%) in Upper middle income and Net enrolment rate(%) in South Africa?
Keep it short and to the point. -4.64. What is the ratio of the Net enrolment rate(%) of Arab World in 1999 to that in 2000?
Ensure brevity in your answer.  0.97. What is the ratio of the Net enrolment rate(%) of Upper middle income in 1999 to that in 2000?
Keep it short and to the point. 0.99. What is the ratio of the Net enrolment rate(%) in South Africa in 1999 to that in 2000?
Make the answer very short. 1.02. What is the ratio of the Net enrolment rate(%) in Arab World in 1999 to that in 2001?
Offer a terse response. 0.94. What is the ratio of the Net enrolment rate(%) in Europe(all income levels) in 1999 to that in 2001?
Provide a short and direct response. 0.97. What is the ratio of the Net enrolment rate(%) of Upper middle income in 1999 to that in 2001?
Your answer should be very brief. 0.98. What is the ratio of the Net enrolment rate(%) of South Africa in 1999 to that in 2001?
Offer a very short reply. 1.01. What is the ratio of the Net enrolment rate(%) in Arab World in 1999 to that in 2002?
Offer a very short reply. 0.92. What is the ratio of the Net enrolment rate(%) in Europe(all income levels) in 1999 to that in 2002?
Provide a short and direct response. 0.97. What is the ratio of the Net enrolment rate(%) in Upper middle income in 1999 to that in 2002?
Your answer should be very brief. 0.97. What is the ratio of the Net enrolment rate(%) of Arab World in 1999 to that in 2003?
Give a very brief answer. 0.88. What is the ratio of the Net enrolment rate(%) of Europe(all income levels) in 1999 to that in 2003?
Make the answer very short. 0.96. What is the ratio of the Net enrolment rate(%) of Upper middle income in 1999 to that in 2003?
Keep it short and to the point. 0.95. What is the ratio of the Net enrolment rate(%) in South Africa in 1999 to that in 2003?
Make the answer very short. 0.96. What is the ratio of the Net enrolment rate(%) of Arab World in 1999 to that in 2004?
Ensure brevity in your answer.  0.86. What is the ratio of the Net enrolment rate(%) of Europe(all income levels) in 1999 to that in 2004?
Provide a succinct answer. 0.97. What is the ratio of the Net enrolment rate(%) of Upper middle income in 1999 to that in 2004?
Your answer should be compact. 0.92. What is the ratio of the Net enrolment rate(%) in South Africa in 1999 to that in 2004?
Make the answer very short. 0.94. What is the ratio of the Net enrolment rate(%) in Arab World in 1999 to that in 2005?
Your answer should be very brief. 0.85. What is the ratio of the Net enrolment rate(%) of Europe(all income levels) in 1999 to that in 2005?
Your response must be concise. 0.96. What is the ratio of the Net enrolment rate(%) in Upper middle income in 1999 to that in 2005?
Provide a succinct answer. 0.9. What is the ratio of the Net enrolment rate(%) of South Africa in 1999 to that in 2005?
Provide a succinct answer. 0.92. What is the ratio of the Net enrolment rate(%) of Arab World in 2000 to that in 2001?
Provide a succinct answer. 0.97. What is the ratio of the Net enrolment rate(%) in Europe(all income levels) in 2000 to that in 2001?
Make the answer very short. 0.99. What is the ratio of the Net enrolment rate(%) of Upper middle income in 2000 to that in 2001?
Give a very brief answer. 0.98. What is the ratio of the Net enrolment rate(%) of Arab World in 2000 to that in 2002?
Offer a very short reply. 0.95. What is the ratio of the Net enrolment rate(%) in Europe(all income levels) in 2000 to that in 2002?
Give a very brief answer. 0.98. What is the ratio of the Net enrolment rate(%) of Upper middle income in 2000 to that in 2002?
Your answer should be very brief. 0.97. What is the ratio of the Net enrolment rate(%) of South Africa in 2000 to that in 2002?
Your answer should be very brief. 0.96. What is the ratio of the Net enrolment rate(%) of Arab World in 2000 to that in 2003?
Offer a very short reply. 0.91. What is the ratio of the Net enrolment rate(%) of Europe(all income levels) in 2000 to that in 2003?
Your answer should be very brief. 0.98. What is the ratio of the Net enrolment rate(%) in Upper middle income in 2000 to that in 2003?
Your answer should be compact. 0.95. What is the ratio of the Net enrolment rate(%) of South Africa in 2000 to that in 2003?
Provide a short and direct response. 0.94. What is the ratio of the Net enrolment rate(%) of Arab World in 2000 to that in 2004?
Your answer should be very brief. 0.88. What is the ratio of the Net enrolment rate(%) of Europe(all income levels) in 2000 to that in 2004?
Your response must be concise. 0.98. What is the ratio of the Net enrolment rate(%) of Upper middle income in 2000 to that in 2004?
Keep it short and to the point. 0.93. What is the ratio of the Net enrolment rate(%) in South Africa in 2000 to that in 2004?
Your answer should be compact. 0.92. What is the ratio of the Net enrolment rate(%) in Arab World in 2000 to that in 2005?
Your answer should be compact. 0.87. What is the ratio of the Net enrolment rate(%) of Europe(all income levels) in 2000 to that in 2005?
Make the answer very short. 0.98. What is the ratio of the Net enrolment rate(%) of Upper middle income in 2000 to that in 2005?
Give a very brief answer. 0.91. What is the ratio of the Net enrolment rate(%) of South Africa in 2000 to that in 2005?
Your answer should be very brief. 0.9. What is the ratio of the Net enrolment rate(%) in Arab World in 2001 to that in 2002?
Your answer should be very brief. 0.98. What is the ratio of the Net enrolment rate(%) of Europe(all income levels) in 2001 to that in 2002?
Keep it short and to the point. 1. What is the ratio of the Net enrolment rate(%) in Upper middle income in 2001 to that in 2002?
Give a very brief answer. 0.99. What is the ratio of the Net enrolment rate(%) of South Africa in 2001 to that in 2002?
Offer a terse response. 0.97. What is the ratio of the Net enrolment rate(%) of Arab World in 2001 to that in 2003?
Offer a terse response. 0.94. What is the ratio of the Net enrolment rate(%) in Europe(all income levels) in 2001 to that in 2003?
Your answer should be very brief. 0.99. What is the ratio of the Net enrolment rate(%) in Upper middle income in 2001 to that in 2003?
Provide a succinct answer. 0.97. What is the ratio of the Net enrolment rate(%) of South Africa in 2001 to that in 2003?
Offer a very short reply. 0.95. What is the ratio of the Net enrolment rate(%) in Arab World in 2001 to that in 2004?
Ensure brevity in your answer.  0.91. What is the ratio of the Net enrolment rate(%) in Europe(all income levels) in 2001 to that in 2004?
Keep it short and to the point. 0.99. What is the ratio of the Net enrolment rate(%) in Upper middle income in 2001 to that in 2004?
Ensure brevity in your answer.  0.94. What is the ratio of the Net enrolment rate(%) of South Africa in 2001 to that in 2004?
Your answer should be compact. 0.93. What is the ratio of the Net enrolment rate(%) in Arab World in 2001 to that in 2005?
Your response must be concise. 0.9. What is the ratio of the Net enrolment rate(%) in Europe(all income levels) in 2001 to that in 2005?
Ensure brevity in your answer.  0.99. What is the ratio of the Net enrolment rate(%) of Upper middle income in 2001 to that in 2005?
Your answer should be compact. 0.92. What is the ratio of the Net enrolment rate(%) of South Africa in 2001 to that in 2005?
Provide a succinct answer. 0.91. What is the ratio of the Net enrolment rate(%) in Upper middle income in 2002 to that in 2003?
Provide a short and direct response. 0.98. What is the ratio of the Net enrolment rate(%) in South Africa in 2002 to that in 2003?
Ensure brevity in your answer.  0.97. What is the ratio of the Net enrolment rate(%) in Arab World in 2002 to that in 2004?
Your answer should be compact. 0.93. What is the ratio of the Net enrolment rate(%) of Europe(all income levels) in 2002 to that in 2004?
Keep it short and to the point. 0.99. What is the ratio of the Net enrolment rate(%) in Upper middle income in 2002 to that in 2004?
Your answer should be very brief. 0.95. What is the ratio of the Net enrolment rate(%) of South Africa in 2002 to that in 2004?
Offer a very short reply. 0.95. What is the ratio of the Net enrolment rate(%) of Arab World in 2002 to that in 2005?
Make the answer very short. 0.92. What is the ratio of the Net enrolment rate(%) of Europe(all income levels) in 2002 to that in 2005?
Provide a succinct answer. 0.99. What is the ratio of the Net enrolment rate(%) in Upper middle income in 2002 to that in 2005?
Give a very brief answer. 0.93. What is the ratio of the Net enrolment rate(%) in South Africa in 2002 to that in 2005?
Offer a very short reply. 0.94. What is the ratio of the Net enrolment rate(%) in Arab World in 2003 to that in 2004?
Provide a short and direct response. 0.97. What is the ratio of the Net enrolment rate(%) in Upper middle income in 2003 to that in 2004?
Give a very brief answer. 0.97. What is the ratio of the Net enrolment rate(%) of South Africa in 2003 to that in 2004?
Your response must be concise. 0.98. What is the ratio of the Net enrolment rate(%) in Arab World in 2003 to that in 2005?
Your response must be concise. 0.96. What is the ratio of the Net enrolment rate(%) of Europe(all income levels) in 2003 to that in 2005?
Offer a very short reply. 1. What is the ratio of the Net enrolment rate(%) in Upper middle income in 2003 to that in 2005?
Your answer should be compact. 0.95. What is the ratio of the Net enrolment rate(%) in South Africa in 2003 to that in 2005?
Your response must be concise. 0.96. What is the ratio of the Net enrolment rate(%) in Upper middle income in 2004 to that in 2005?
Your response must be concise. 0.98. What is the ratio of the Net enrolment rate(%) of South Africa in 2004 to that in 2005?
Offer a very short reply. 0.98. What is the difference between the highest and the second highest Net enrolment rate(%) in Arab World?
Your response must be concise. 0.31. What is the difference between the highest and the second highest Net enrolment rate(%) of Europe(all income levels)?
Make the answer very short. 0.04. What is the difference between the highest and the second highest Net enrolment rate(%) in Upper middle income?
Your answer should be compact. 1.5. What is the difference between the highest and the second highest Net enrolment rate(%) of South Africa?
Provide a short and direct response. 1.16. What is the difference between the highest and the lowest Net enrolment rate(%) of Arab World?
Give a very brief answer. 8.16. What is the difference between the highest and the lowest Net enrolment rate(%) of Europe(all income levels)?
Provide a short and direct response. 3.13. What is the difference between the highest and the lowest Net enrolment rate(%) in Upper middle income?
Ensure brevity in your answer.  6.36. What is the difference between the highest and the lowest Net enrolment rate(%) in South Africa?
Offer a terse response. 6.6. 